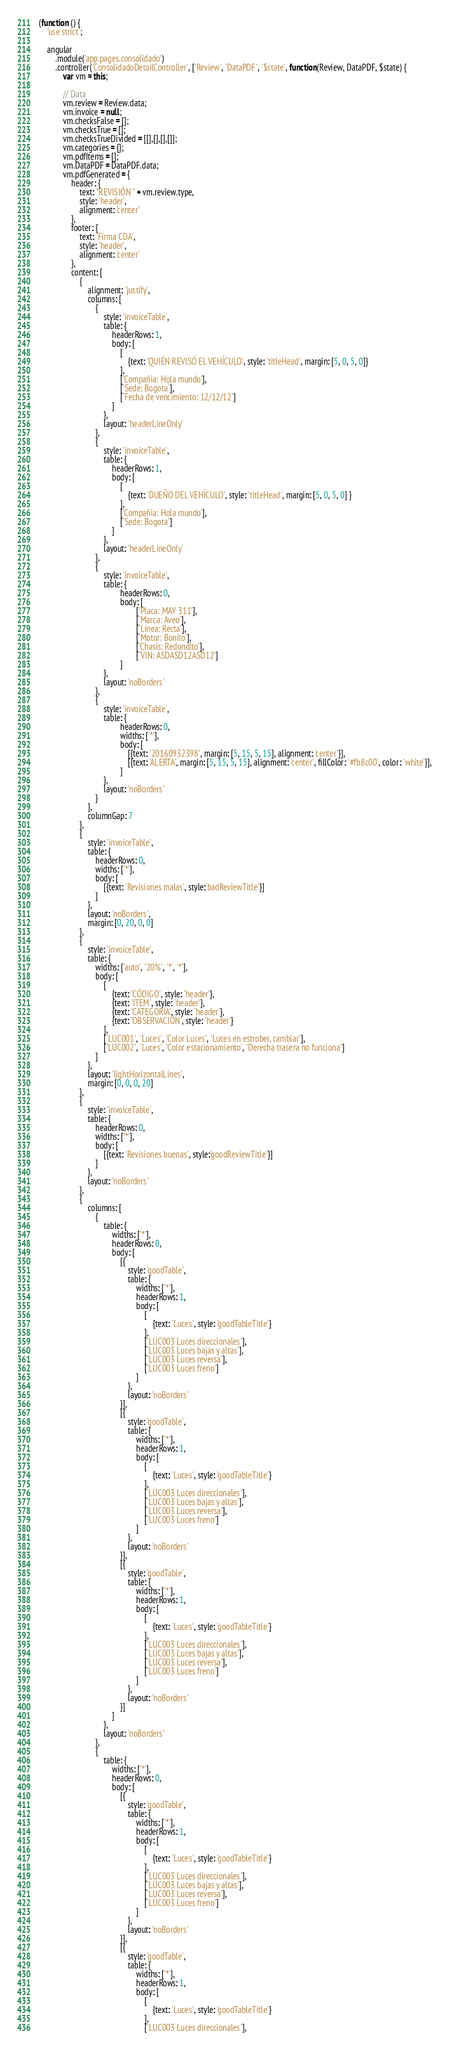Convert code to text. <code><loc_0><loc_0><loc_500><loc_500><_JavaScript_>(function () {
    'use strict';

    angular
        .module('app.pages.consolidado')
        .controller('ConsolidadoDetailController', ['Review', 'DataPDF', '$state', function(Review, DataPDF, $state) {
            var vm = this;

            // Data
            vm.review = Review.data;
            vm.invoice = null;
            vm.checksFalse = [];
            vm.checksTrue = [];
            vm.checksTrueDivided = [[],[],[],[]];
            vm.categories = {};
            vm.pdfItems = [];
            vm.DataPDF = DataPDF.data;
            vm.pdfGenerated = {
                header: { 
                    text: "REVISIÓN " + vm.review.type,
                    style: 'header', 
			        alignment: 'center'
                },
                footer: {         
			        text: 'Firma CDA', 
			        style: 'header', 
			        alignment: 'center'
                },
                content: [
                    {
                        alignment: 'justify',
                        columns: [
                            {
                                style: 'invoiceTable',
                                table: {
                                    headerRows: 1,
                                    body: [
                                        [
                                            {text: 'QUIÉN REVISÓ EL VEHÍCULO', style: 'titleHead', margin: [5, 0, 5, 0]}
                                        ],
                                        ['Compañia: Hola mundo'],
                                        ['Sede: Bogota'],
                                        ['Fecha de vencimiento: 12/12/12']
                                    ]
                                },
                                layout: 'headerLineOnly'
                            },
                            {
                                style: 'invoiceTable',
                                table: {
                                    headerRows: 1,
                                    body: [
                                        [
                                            {text: 'DUEÑO DEL VEHÍCULO', style: 'titleHead', margin: [5, 0, 5, 0] }
                                        ],
                                        ['Compañia: Hola mundo'],
                                        ['Sede: Bogota']
                                    ]
                                },
                                layout: 'headerLineOnly'
                            },
                            {
                                style: 'invoiceTable',
                                table: {
                                        headerRows: 0,
                                        body: [
                                                ['Placa: MAY 311'],
                                                ['Marca: Aveo'],
                                                ['Línea: Recta'],
                                                ['Motor: Bonito'],
                                                ['Chasis: Redondito'],
                                                ['VIN: ASDASD12ASD12']
                                        ]
                                },
                                layout: 'noBorders'
                            },
                            {
                                style: 'invoiceTable',
                                table: {
                                        headerRows: 0,
                                        widths: ['*'],
                                        body: [
                                            [{text: '20160932398', margin: [5, 15, 5, 15], alignment: 'center'}],
                                            [{text: 'ALERTA', margin: [5, 15, 5, 15], alignment: 'center', fillColor: '#fb8c00', color: 'white'}],
                                        ]
                                },
                                layout: 'noBorders'
                            }
                        ],
                        columnGap: 7
                    },
                    {
                        style: 'invoiceTable',
                        table: {
                            headerRows: 0,
                            widths: ['*'],
                            body: [
                                [{text: 'Revisiones malas', style:'badReviewTitle'}]
                            ]
                        },
                        layout: 'noBorders',
                        margin: [0, 20, 0, 0]
                    },
                    {
                        style: 'invoiceTable',
                        table: {
                            widths: ['auto', '20%', '*', '*'],
                            body: [
                                [
                                    {text: 'CÓDIGO', style: 'header'}, 
                                    {text: 'ITEM', style: 'header'},
                                    {text: 'CATEGORÍA', style: 'header'},
                                    {text: 'OBSERVACIÓN', style: 'header'}
                                ],
                                ['LUC001', 'Luces', 'Color Luces', 'Luces en estrober, cambiar'],
                                ['LUC002', 'Luces', 'Color estacionamiento', 'Derecha trasera no funciona']
                            ]
                        },
                        layout: 'lightHorizontalLines',
                        margin: [0, 0, 0, 20]
                    },
                    {
                        style: 'invoiceTable',
                        table: {
                            headerRows: 0,
                            widths: ['*'],
                            body: [
                                [{text: 'Revisiones buenas', style:'goodReviewTitle'}]
                            ]
                        },
                        layout: 'noBorders'
                    },
                    {
                        columns: [
                            {
                                table: {
                                    widths: ['*'],
                                    headerRows: 0,
                                    body: [
                                        [{
                                            style: 'goodTable',
                                            table: {
                                                widths: ['*'],
                                                headerRows: 1,
                                                body: [
                                                    [
                                                        {text: 'Luces', style: 'goodTableTitle'}
                                                    ],
                                                    ['LUC003 Luces direccionales'],
                                                    ['LUC003 Luces bajas y altas'],
                                                    ['LUC003 Luces reversa'],
                                                    ['LUC003 Luces freno']
                                                ]
                                            },
                                            layout: 'noBorders'                                            
                                        }],
                                        [{
                                            style: 'goodTable',
                                            table: {
                                                widths: ['*'],
                                                headerRows: 1,
                                                body: [
                                                    [
                                                        {text: 'Luces', style: 'goodTableTitle'}
                                                    ],
                                                    ['LUC003 Luces direccionales'],
                                                    ['LUC003 Luces bajas y altas'],
                                                    ['LUC003 Luces reversa'],
                                                    ['LUC003 Luces freno']
                                                ]
                                            },
                                            layout: 'noBorders'                                            
                                        }],
                                        [{
                                            style: 'goodTable',
                                            table: {
                                                widths: ['*'],
                                                headerRows: 1,
                                                body: [
                                                    [
                                                        {text: 'Luces', style: 'goodTableTitle'}
                                                    ],
                                                    ['LUC003 Luces direccionales'],
                                                    ['LUC003 Luces bajas y altas'],
                                                    ['LUC003 Luces reversa'],
                                                    ['LUC003 Luces freno']
                                                ]
                                            },
                                            layout: 'noBorders'                                            
                                        }]
                                    ]
                                },
                                layout: 'noBorders'
                            },
                            {
                                table: {
                                    widths: ['*'],
                                    headerRows: 0,
                                    body: [
                                        [{
                                            style: 'goodTable',
                                            table: {
                                                widths: ['*'],
                                                headerRows: 1,
                                                body: [
                                                    [
                                                        {text: 'Luces', style: 'goodTableTitle'}
                                                    ],
                                                    ['LUC003 Luces direccionales'],
                                                    ['LUC003 Luces bajas y altas'],
                                                    ['LUC003 Luces reversa'],
                                                    ['LUC003 Luces freno']
                                                ]
                                            },
                                            layout: 'noBorders'                                            
                                        }],
                                        [{
                                            style: 'goodTable',
                                            table: {
                                                widths: ['*'],
                                                headerRows: 1,
                                                body: [
                                                    [
                                                        {text: 'Luces', style: 'goodTableTitle'}
                                                    ],
                                                    ['LUC003 Luces direccionales'],</code> 